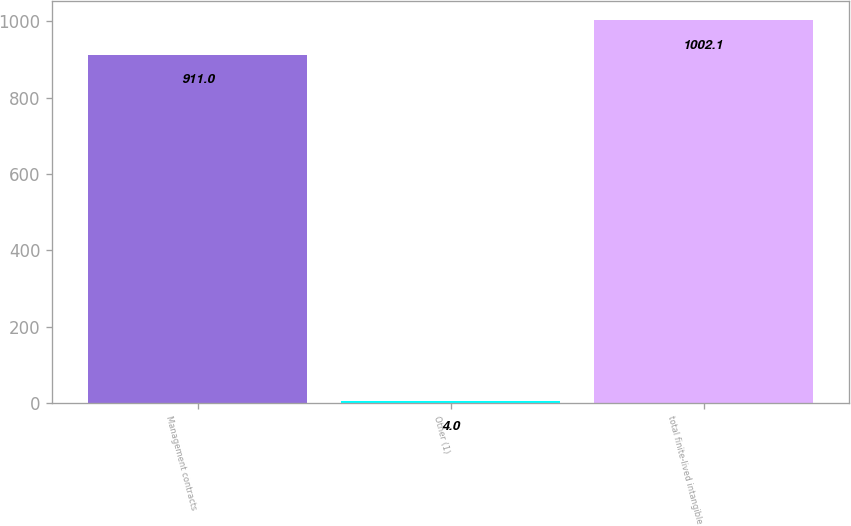Convert chart. <chart><loc_0><loc_0><loc_500><loc_500><bar_chart><fcel>Management contracts<fcel>Other (1)<fcel>total finite-lived intangible<nl><fcel>911<fcel>4<fcel>1002.1<nl></chart> 